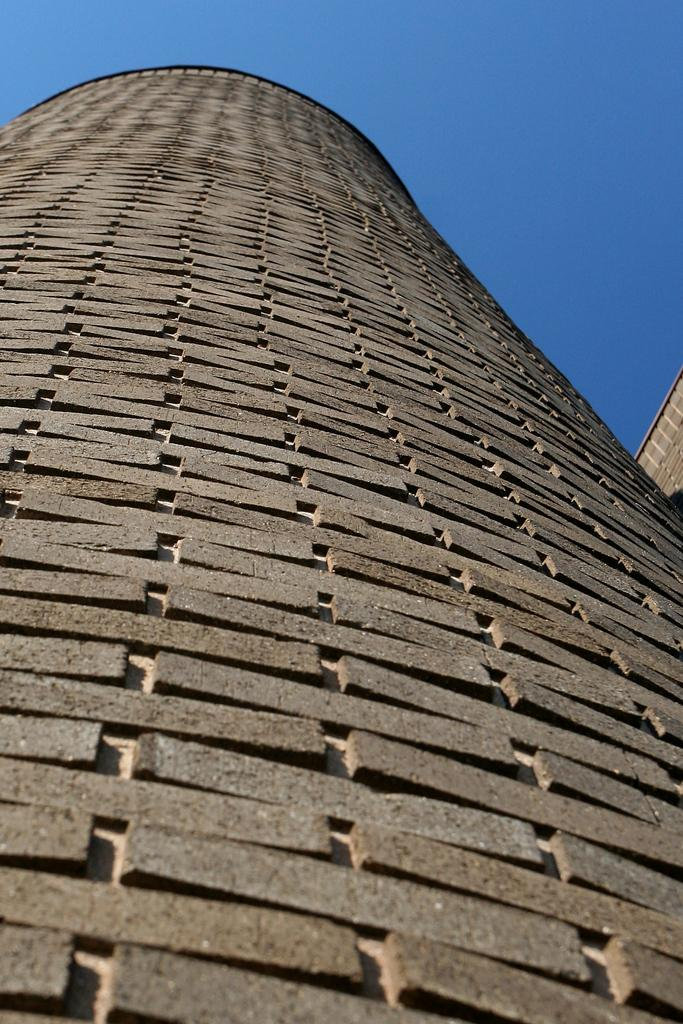What is located in the center of the image? There are buildings in the center of the image. What can be seen in the background of the image? The sky is visible in the background of the image. Where is the rabbit's nest located in the image? There is no rabbit or nest present in the image. What type of connection can be seen between the buildings in the image? The image does not show any specific connections between the buildings; it only shows their general arrangement. 